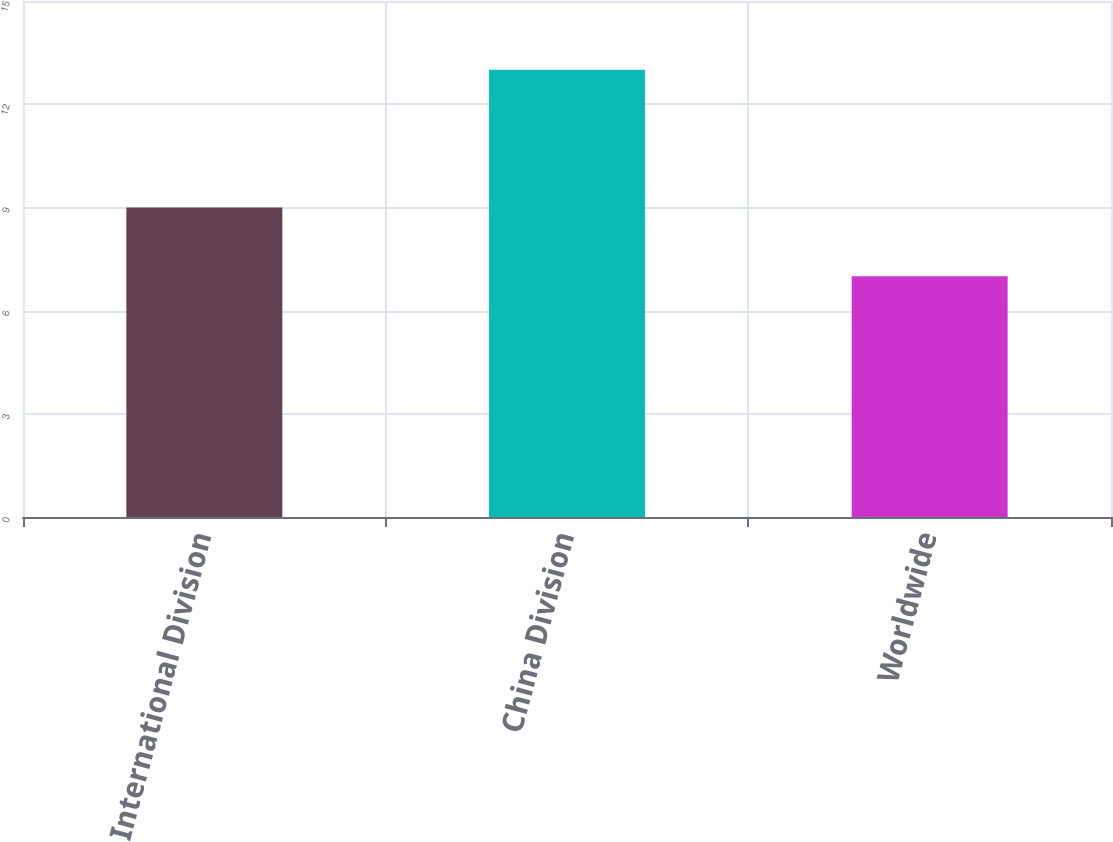Convert chart to OTSL. <chart><loc_0><loc_0><loc_500><loc_500><bar_chart><fcel>International Division<fcel>China Division<fcel>Worldwide<nl><fcel>9<fcel>13<fcel>7<nl></chart> 